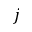<formula> <loc_0><loc_0><loc_500><loc_500>j</formula> 